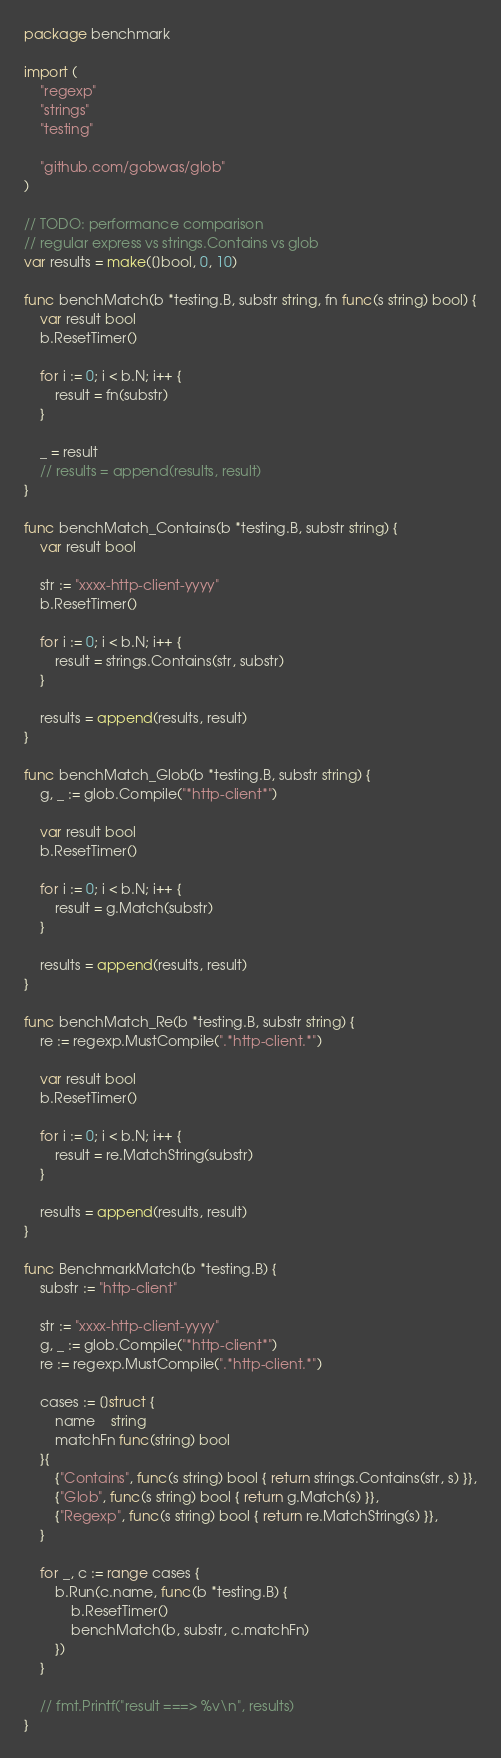<code> <loc_0><loc_0><loc_500><loc_500><_Go_>package benchmark

import (
	"regexp"
	"strings"
	"testing"

	"github.com/gobwas/glob"
)

// TODO: performance comparison
// regular express vs strings.Contains vs glob
var results = make([]bool, 0, 10)

func benchMatch(b *testing.B, substr string, fn func(s string) bool) {
	var result bool
	b.ResetTimer()

	for i := 0; i < b.N; i++ {
		result = fn(substr)
	}

	_ = result
	// results = append(results, result)
}

func benchMatch_Contains(b *testing.B, substr string) {
	var result bool

	str := "xxxx-http-client-yyyy"
	b.ResetTimer()

	for i := 0; i < b.N; i++ {
		result = strings.Contains(str, substr)
	}

	results = append(results, result)
}

func benchMatch_Glob(b *testing.B, substr string) {
	g, _ := glob.Compile("*http-client*")

	var result bool
	b.ResetTimer()

	for i := 0; i < b.N; i++ {
		result = g.Match(substr)
	}

	results = append(results, result)
}

func benchMatch_Re(b *testing.B, substr string) {
	re := regexp.MustCompile(".*http-client.*")

	var result bool
	b.ResetTimer()

	for i := 0; i < b.N; i++ {
		result = re.MatchString(substr)
	}

	results = append(results, result)
}

func BenchmarkMatch(b *testing.B) {
	substr := "http-client"

	str := "xxxx-http-client-yyyy"
	g, _ := glob.Compile("*http-client*")
	re := regexp.MustCompile(".*http-client.*")

	cases := []struct {
		name    string
		matchFn func(string) bool
	}{
		{"Contains", func(s string) bool { return strings.Contains(str, s) }},
		{"Glob", func(s string) bool { return g.Match(s) }},
		{"Regexp", func(s string) bool { return re.MatchString(s) }},
	}

	for _, c := range cases {
		b.Run(c.name, func(b *testing.B) {
			b.ResetTimer()
			benchMatch(b, substr, c.matchFn)
		})
	}

	// fmt.Printf("result ===> %v\n", results)
}
</code> 